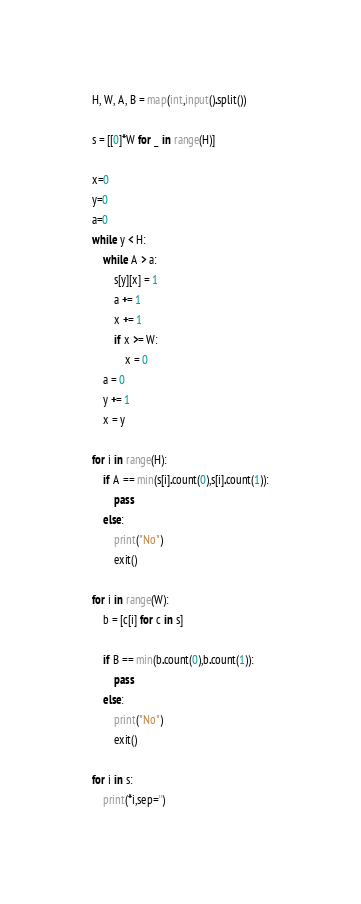<code> <loc_0><loc_0><loc_500><loc_500><_Python_>H, W, A, B = map(int,input().split())

s = [[0]*W for _ in range(H)]

x=0
y=0
a=0
while y < H:
    while A > a:
        s[y][x] = 1
        a += 1
        x += 1
        if x >= W:
            x = 0
    a = 0
    y += 1
    x = y

for i in range(H):
    if A == min(s[i].count(0),s[i].count(1)):
        pass
    else:
        print("No")
        exit()

for i in range(W):
    b = [c[i] for c in s]

    if B == min(b.count(0),b.count(1)):
        pass
    else:
        print("No")
        exit()

for i in s:
    print(*i,sep='')
</code> 